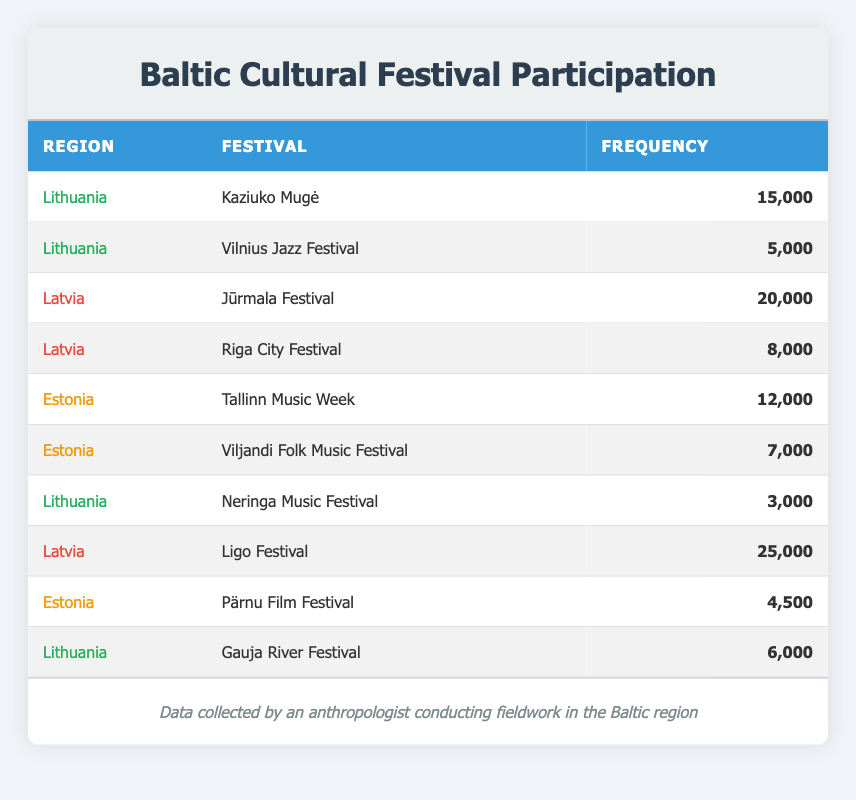What is the frequency of participation in the Kaziuko Mugė festival in Lithuania? The table lists Kaziuko Mugė under the Lithuania region with a frequency of 15,000 participants.
Answer: 15,000 Which festival in Latvia has the highest participation frequency? From the table, Ligo Festival has the highest frequency with 25,000 participants, compared to the Jūrmala Festival (20,000) and Riga City Festival (8,000).
Answer: Ligo Festival How many total participants attended festivals in Lithuania? Summing the frequencies of Lithuanian festivals: Kaziuko Mugė (15,000) + Vilnius Jazz Festival (5,000) + Neringa Music Festival (3,000) + Gauja River Festival (6,000) = 29,000.
Answer: 29,000 Is the frequency of participation in the Pärnu Film Festival greater than that in Viljandi Folk Music Festival? The Pärnu Film Festival has a frequency of 4,500, while the Viljandi Folk Music Festival reports 7,000 participants. Thus, 4,500 is not greater than 7,000.
Answer: No What is the average frequency of participation in festivals held in Estonia? Adding the frequencies for Estonia: Tallinn Music Week (12,000) + Viljandi Folk Music Festival (7,000) + Pärnu Film Festival (4,500) gives a total of 23,500. There are three data points, so the average is 23,500 / 3 = 7,833.33, which can be rounded to 7,833.
Answer: 7,833 Which region has a total participation frequency greater than 25,000? The total frequency for Latvia is Ligo Festival (25,000) + Jūrmala Festival (20,000) + Riga City Festival (8,000) = 53,000. Lithuania totals 29,000, while Estonia totals 23,500, indicating only Latvia exceeds 25,000.
Answer: Yes What is the participation frequency difference between the Jūrmala Festival and Riga City Festival? The frequency for Jūrmala Festival is 20,000 and for Riga City Festival is 8,000. The difference is calculated as 20,000 - 8,000 = 12,000.
Answer: 12,000 How many festivals in Lithuania had a frequency less than 10,000? The festivals with frequencies less than 10,000 in Lithuania are Neringa Music Festival (3,000) and Vilnius Jazz Festival (5,000). Therefore, there are two such festivals.
Answer: 2 Which region has the most total participants across all its festivals? Adding up the frequencies: Lithuania (29,000), Latvia (53,000), and Estonia (23,500). Latvia has the highest total of 53,000 participants across its festivals.
Answer: Latvia 